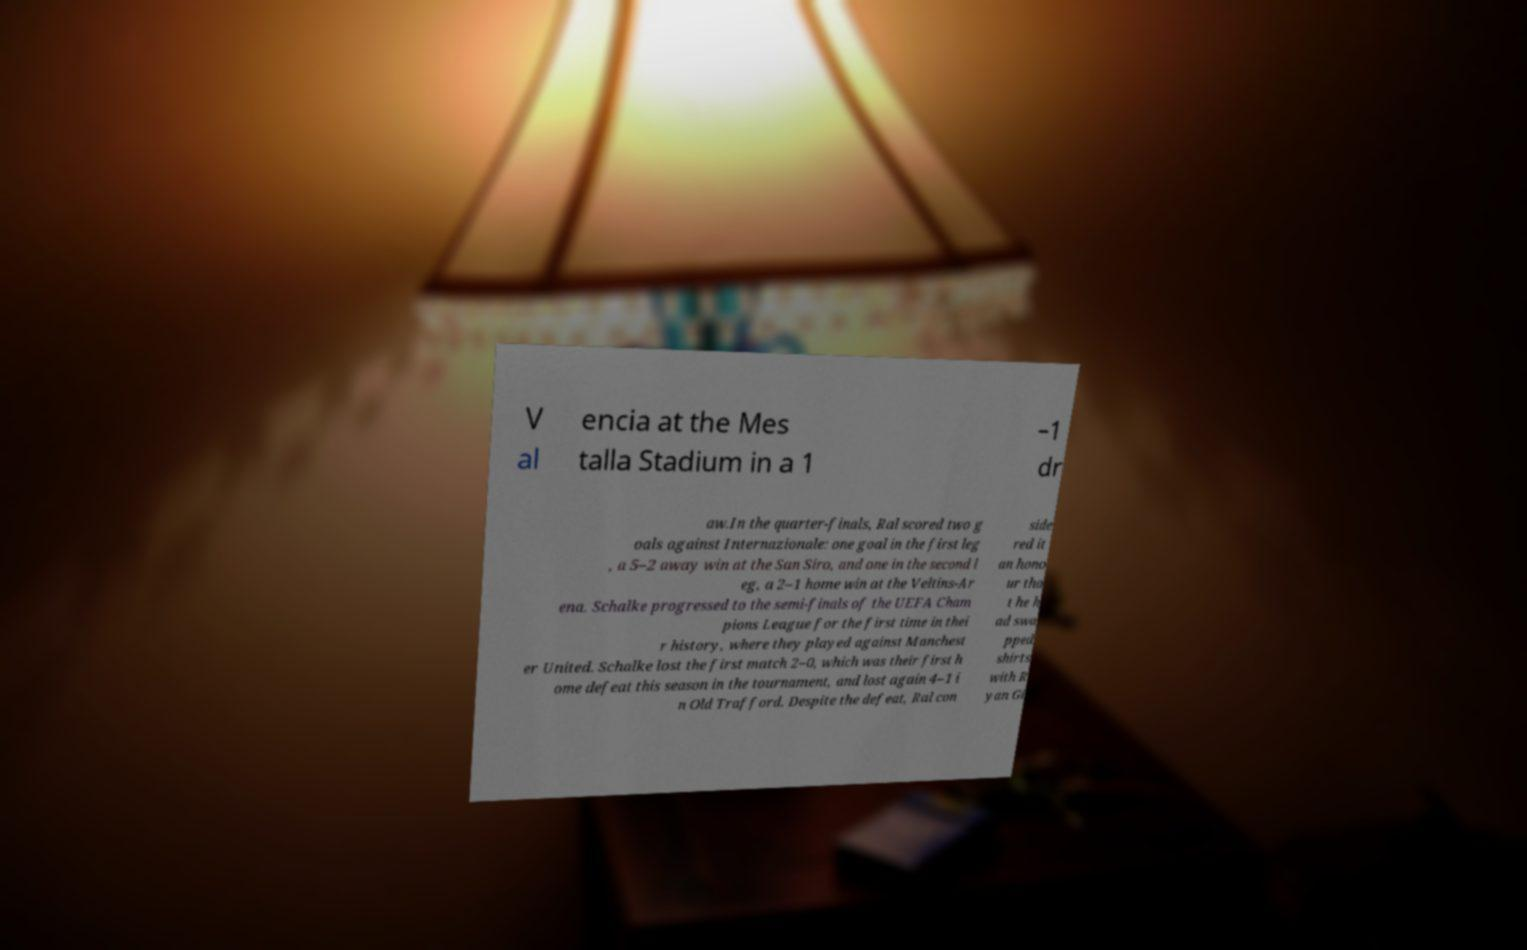Please read and relay the text visible in this image. What does it say? V al encia at the Mes talla Stadium in a 1 –1 dr aw.In the quarter-finals, Ral scored two g oals against Internazionale: one goal in the first leg , a 5–2 away win at the San Siro, and one in the second l eg, a 2–1 home win at the Veltins-Ar ena. Schalke progressed to the semi-finals of the UEFA Cham pions League for the first time in thei r history, where they played against Manchest er United. Schalke lost the first match 2–0, which was their first h ome defeat this season in the tournament, and lost again 4–1 i n Old Trafford. Despite the defeat, Ral con side red it an hono ur tha t he h ad swa pped shirts with R yan Gi 